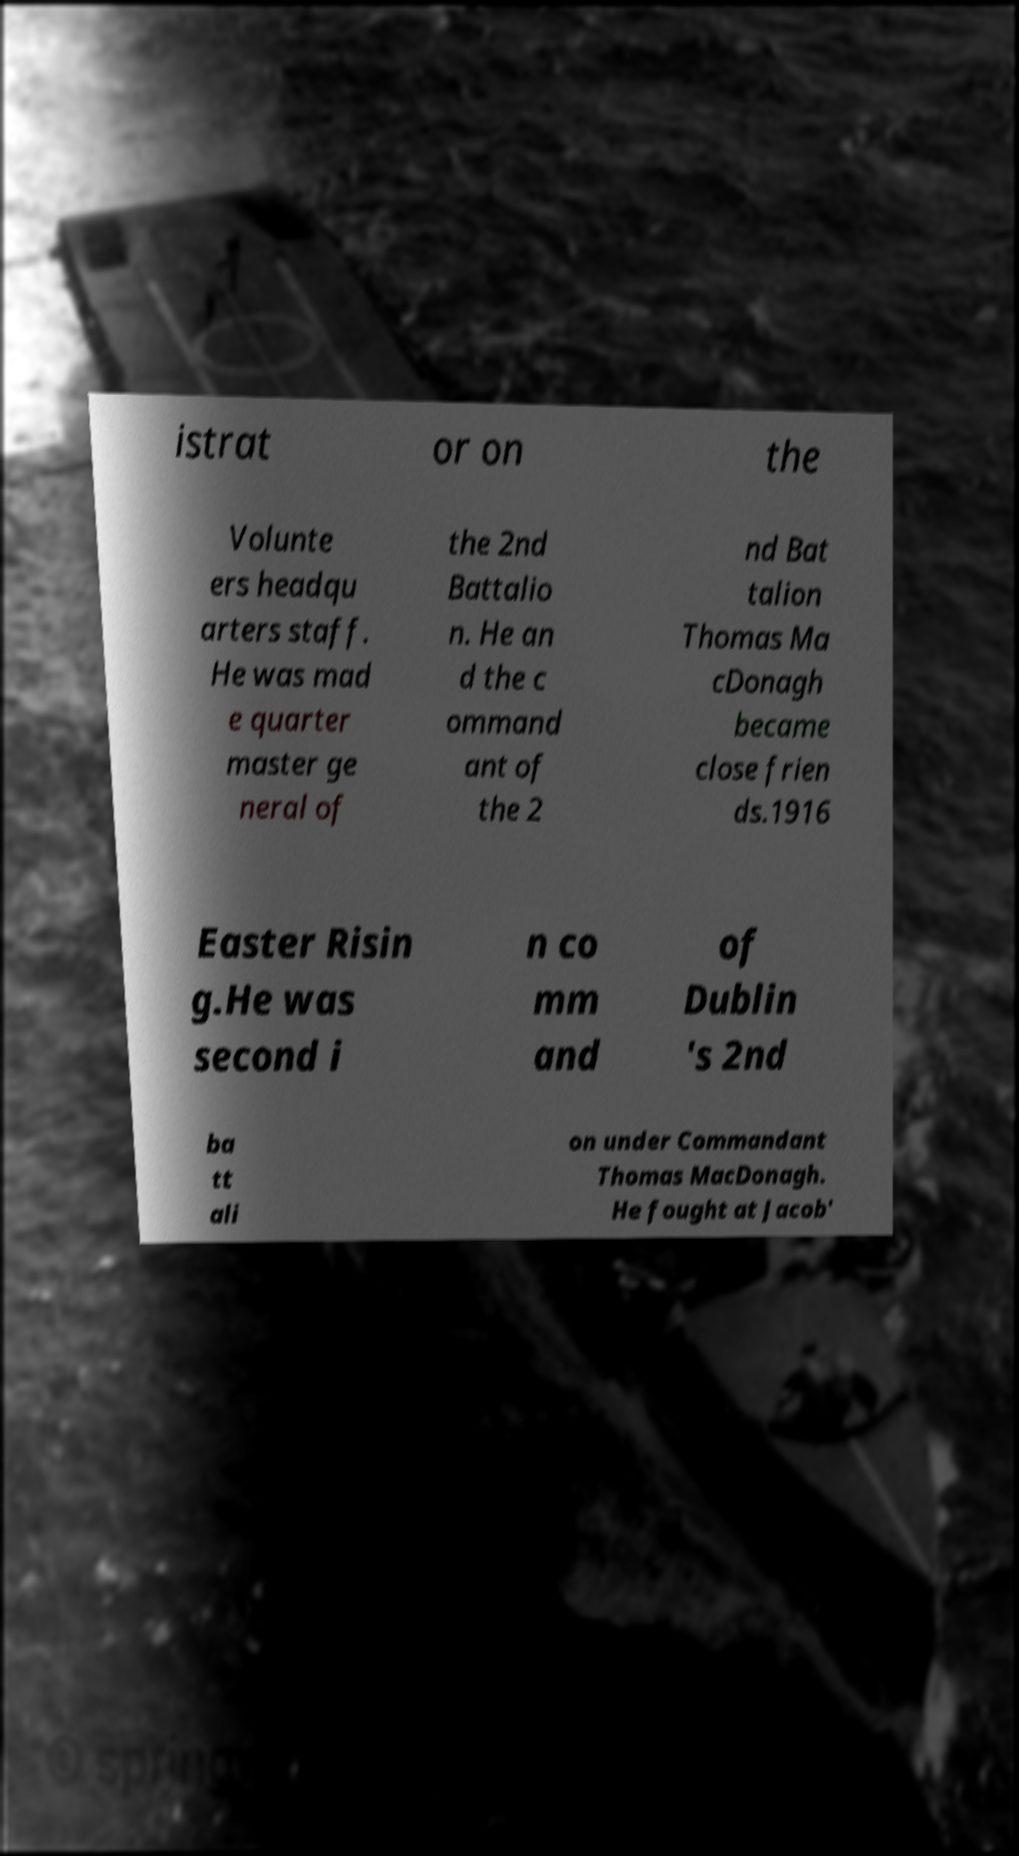Could you assist in decoding the text presented in this image and type it out clearly? istrat or on the Volunte ers headqu arters staff. He was mad e quarter master ge neral of the 2nd Battalio n. He an d the c ommand ant of the 2 nd Bat talion Thomas Ma cDonagh became close frien ds.1916 Easter Risin g.He was second i n co mm and of Dublin 's 2nd ba tt ali on under Commandant Thomas MacDonagh. He fought at Jacob' 